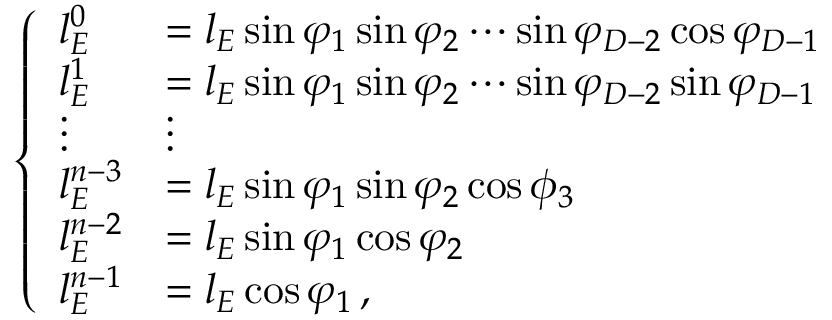Convert formula to latex. <formula><loc_0><loc_0><loc_500><loc_500>\left \{ \begin{array} { l l } { l _ { E } ^ { 0 } } & { = l _ { E } \sin \varphi _ { 1 } \sin \varphi _ { 2 } \cdots \sin \varphi _ { D - 2 } \cos \varphi _ { D - 1 } } \\ { l _ { E } ^ { 1 } } & { = l _ { E } \sin \varphi _ { 1 } \sin \varphi _ { 2 } \cdots \sin \varphi _ { D - 2 } \sin \varphi _ { D - 1 } } \\ { \vdots } & { \vdots } \\ { l _ { E } ^ { n - 3 } } & { = l _ { E } \sin \varphi _ { 1 } \sin \varphi _ { 2 } \cos \phi _ { 3 } } \\ { l _ { E } ^ { n - 2 } } & { = l _ { E } \sin \varphi _ { 1 } \cos \varphi _ { 2 } } \\ { l _ { E } ^ { n - 1 } } & { = l _ { E } \cos \varphi _ { 1 } \, , } \end{array}</formula> 